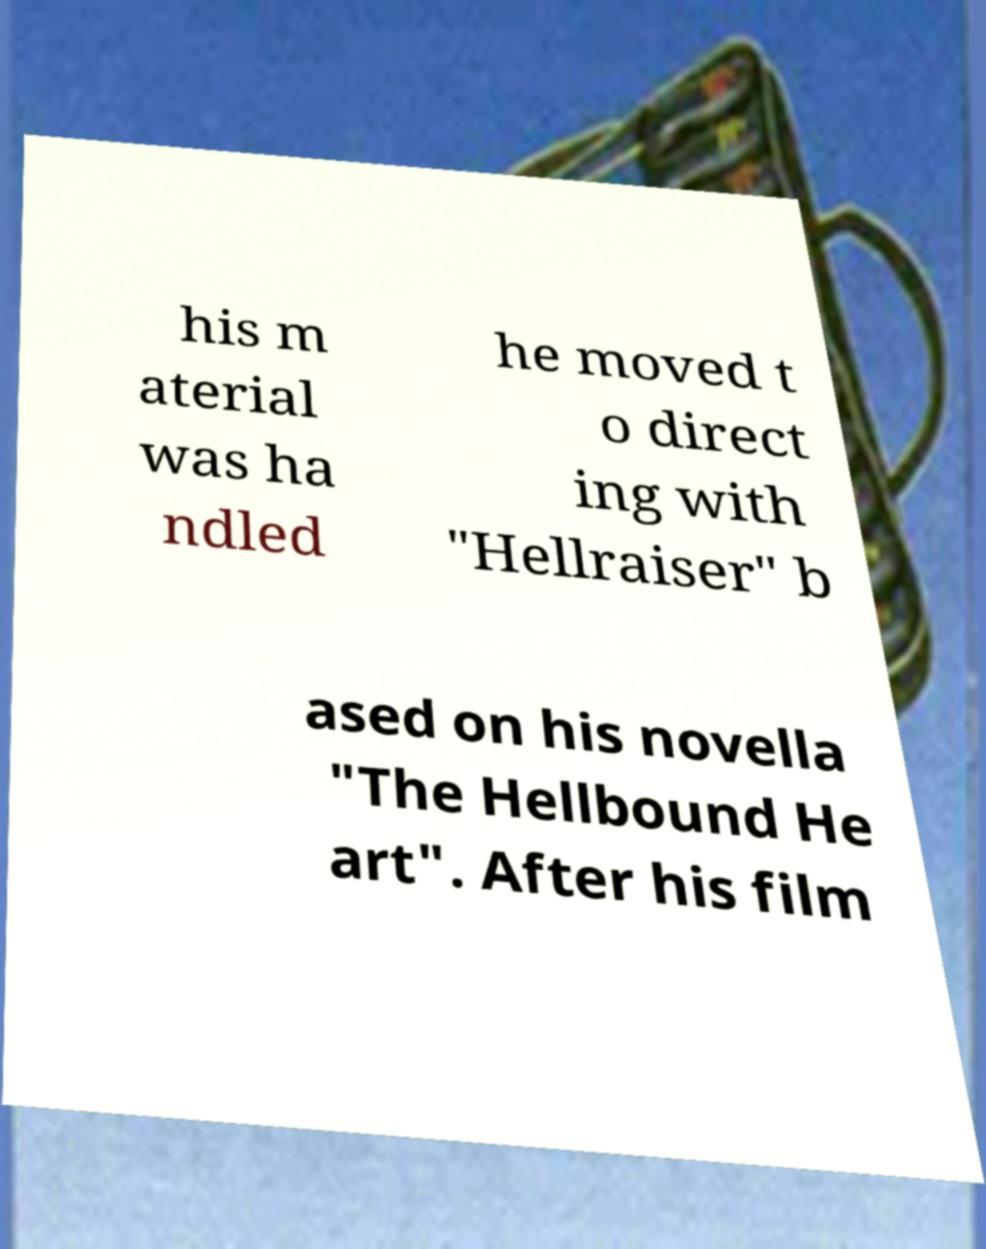Could you assist in decoding the text presented in this image and type it out clearly? his m aterial was ha ndled he moved t o direct ing with "Hellraiser" b ased on his novella "The Hellbound He art". After his film 